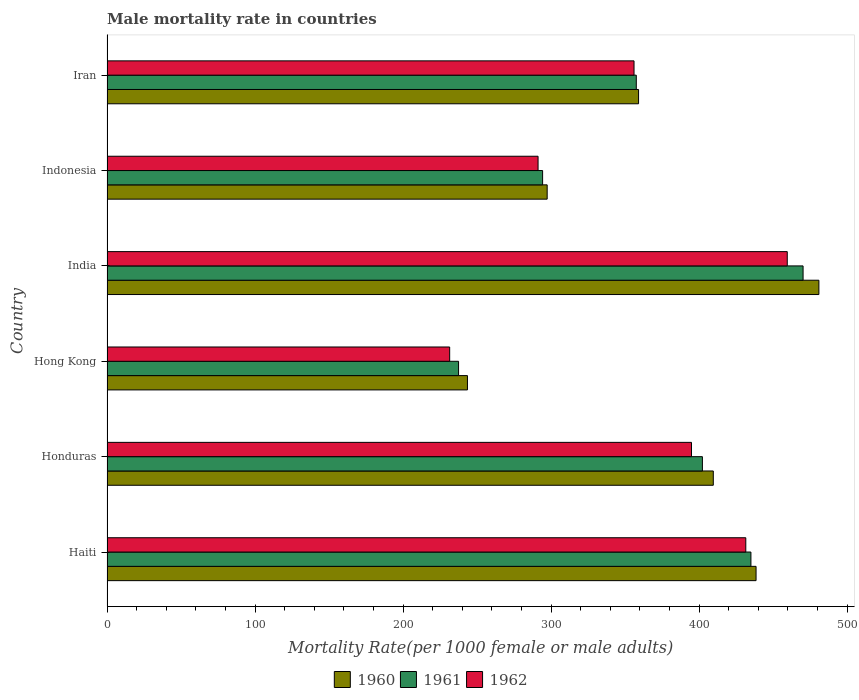How many groups of bars are there?
Keep it short and to the point. 6. How many bars are there on the 3rd tick from the top?
Make the answer very short. 3. What is the label of the 4th group of bars from the top?
Provide a succinct answer. Hong Kong. In how many cases, is the number of bars for a given country not equal to the number of legend labels?
Give a very brief answer. 0. What is the male mortality rate in 1960 in India?
Offer a very short reply. 480.88. Across all countries, what is the maximum male mortality rate in 1962?
Make the answer very short. 459.51. Across all countries, what is the minimum male mortality rate in 1960?
Provide a succinct answer. 243.48. In which country was the male mortality rate in 1962 maximum?
Offer a terse response. India. In which country was the male mortality rate in 1960 minimum?
Provide a succinct answer. Hong Kong. What is the total male mortality rate in 1960 in the graph?
Provide a short and direct response. 2228.73. What is the difference between the male mortality rate in 1961 in Hong Kong and that in India?
Offer a very short reply. -232.72. What is the difference between the male mortality rate in 1960 in India and the male mortality rate in 1962 in Haiti?
Offer a very short reply. 49.38. What is the average male mortality rate in 1960 per country?
Your answer should be compact. 371.46. What is the difference between the male mortality rate in 1960 and male mortality rate in 1961 in Indonesia?
Give a very brief answer. 3.08. What is the ratio of the male mortality rate in 1961 in Haiti to that in India?
Provide a succinct answer. 0.93. What is the difference between the highest and the second highest male mortality rate in 1961?
Your answer should be very brief. 35.23. What is the difference between the highest and the lowest male mortality rate in 1961?
Keep it short and to the point. 232.72. Is the sum of the male mortality rate in 1960 in Hong Kong and Iran greater than the maximum male mortality rate in 1961 across all countries?
Provide a short and direct response. Yes. Is it the case that in every country, the sum of the male mortality rate in 1960 and male mortality rate in 1961 is greater than the male mortality rate in 1962?
Offer a very short reply. Yes. How many bars are there?
Your answer should be compact. 18. Are all the bars in the graph horizontal?
Offer a very short reply. Yes. What is the difference between two consecutive major ticks on the X-axis?
Ensure brevity in your answer.  100. Does the graph contain grids?
Give a very brief answer. No. Where does the legend appear in the graph?
Offer a terse response. Bottom center. How many legend labels are there?
Provide a short and direct response. 3. What is the title of the graph?
Offer a very short reply. Male mortality rate in countries. Does "1975" appear as one of the legend labels in the graph?
Your answer should be compact. No. What is the label or title of the X-axis?
Provide a short and direct response. Mortality Rate(per 1000 female or male adults). What is the label or title of the Y-axis?
Your response must be concise. Country. What is the Mortality Rate(per 1000 female or male adults) of 1960 in Haiti?
Provide a short and direct response. 438.43. What is the Mortality Rate(per 1000 female or male adults) of 1961 in Haiti?
Ensure brevity in your answer.  434.96. What is the Mortality Rate(per 1000 female or male adults) in 1962 in Haiti?
Make the answer very short. 431.5. What is the Mortality Rate(per 1000 female or male adults) in 1960 in Honduras?
Your answer should be compact. 409.55. What is the Mortality Rate(per 1000 female or male adults) in 1961 in Honduras?
Keep it short and to the point. 402.19. What is the Mortality Rate(per 1000 female or male adults) of 1962 in Honduras?
Provide a short and direct response. 394.82. What is the Mortality Rate(per 1000 female or male adults) of 1960 in Hong Kong?
Offer a terse response. 243.48. What is the Mortality Rate(per 1000 female or male adults) in 1961 in Hong Kong?
Ensure brevity in your answer.  237.47. What is the Mortality Rate(per 1000 female or male adults) in 1962 in Hong Kong?
Offer a terse response. 231.47. What is the Mortality Rate(per 1000 female or male adults) of 1960 in India?
Give a very brief answer. 480.88. What is the Mortality Rate(per 1000 female or male adults) of 1961 in India?
Your answer should be very brief. 470.19. What is the Mortality Rate(per 1000 female or male adults) in 1962 in India?
Offer a terse response. 459.51. What is the Mortality Rate(per 1000 female or male adults) in 1960 in Indonesia?
Make the answer very short. 297.33. What is the Mortality Rate(per 1000 female or male adults) of 1961 in Indonesia?
Ensure brevity in your answer.  294.25. What is the Mortality Rate(per 1000 female or male adults) of 1962 in Indonesia?
Your answer should be very brief. 291.18. What is the Mortality Rate(per 1000 female or male adults) of 1960 in Iran?
Make the answer very short. 359.06. What is the Mortality Rate(per 1000 female or male adults) in 1961 in Iran?
Your answer should be very brief. 357.53. What is the Mortality Rate(per 1000 female or male adults) of 1962 in Iran?
Your answer should be compact. 356. Across all countries, what is the maximum Mortality Rate(per 1000 female or male adults) of 1960?
Provide a short and direct response. 480.88. Across all countries, what is the maximum Mortality Rate(per 1000 female or male adults) in 1961?
Provide a short and direct response. 470.19. Across all countries, what is the maximum Mortality Rate(per 1000 female or male adults) in 1962?
Offer a terse response. 459.51. Across all countries, what is the minimum Mortality Rate(per 1000 female or male adults) in 1960?
Make the answer very short. 243.48. Across all countries, what is the minimum Mortality Rate(per 1000 female or male adults) of 1961?
Provide a succinct answer. 237.47. Across all countries, what is the minimum Mortality Rate(per 1000 female or male adults) in 1962?
Your answer should be very brief. 231.47. What is the total Mortality Rate(per 1000 female or male adults) in 1960 in the graph?
Provide a succinct answer. 2228.73. What is the total Mortality Rate(per 1000 female or male adults) in 1961 in the graph?
Keep it short and to the point. 2196.6. What is the total Mortality Rate(per 1000 female or male adults) in 1962 in the graph?
Offer a terse response. 2164.47. What is the difference between the Mortality Rate(per 1000 female or male adults) of 1960 in Haiti and that in Honduras?
Keep it short and to the point. 28.88. What is the difference between the Mortality Rate(per 1000 female or male adults) in 1961 in Haiti and that in Honduras?
Provide a short and direct response. 32.78. What is the difference between the Mortality Rate(per 1000 female or male adults) of 1962 in Haiti and that in Honduras?
Make the answer very short. 36.67. What is the difference between the Mortality Rate(per 1000 female or male adults) of 1960 in Haiti and that in Hong Kong?
Your response must be concise. 194.96. What is the difference between the Mortality Rate(per 1000 female or male adults) of 1961 in Haiti and that in Hong Kong?
Make the answer very short. 197.49. What is the difference between the Mortality Rate(per 1000 female or male adults) of 1962 in Haiti and that in Hong Kong?
Ensure brevity in your answer.  200.03. What is the difference between the Mortality Rate(per 1000 female or male adults) in 1960 in Haiti and that in India?
Provide a short and direct response. -42.45. What is the difference between the Mortality Rate(per 1000 female or male adults) of 1961 in Haiti and that in India?
Provide a succinct answer. -35.23. What is the difference between the Mortality Rate(per 1000 female or male adults) of 1962 in Haiti and that in India?
Your response must be concise. -28.01. What is the difference between the Mortality Rate(per 1000 female or male adults) in 1960 in Haiti and that in Indonesia?
Provide a succinct answer. 141.1. What is the difference between the Mortality Rate(per 1000 female or male adults) of 1961 in Haiti and that in Indonesia?
Provide a succinct answer. 140.71. What is the difference between the Mortality Rate(per 1000 female or male adults) in 1962 in Haiti and that in Indonesia?
Ensure brevity in your answer.  140.32. What is the difference between the Mortality Rate(per 1000 female or male adults) of 1960 in Haiti and that in Iran?
Your response must be concise. 79.37. What is the difference between the Mortality Rate(per 1000 female or male adults) of 1961 in Haiti and that in Iran?
Give a very brief answer. 77.44. What is the difference between the Mortality Rate(per 1000 female or male adults) of 1962 in Haiti and that in Iran?
Keep it short and to the point. 75.5. What is the difference between the Mortality Rate(per 1000 female or male adults) in 1960 in Honduras and that in Hong Kong?
Give a very brief answer. 166.07. What is the difference between the Mortality Rate(per 1000 female or male adults) of 1961 in Honduras and that in Hong Kong?
Your answer should be compact. 164.71. What is the difference between the Mortality Rate(per 1000 female or male adults) in 1962 in Honduras and that in Hong Kong?
Your answer should be very brief. 163.35. What is the difference between the Mortality Rate(per 1000 female or male adults) of 1960 in Honduras and that in India?
Ensure brevity in your answer.  -71.33. What is the difference between the Mortality Rate(per 1000 female or male adults) of 1961 in Honduras and that in India?
Provide a short and direct response. -68.01. What is the difference between the Mortality Rate(per 1000 female or male adults) in 1962 in Honduras and that in India?
Your response must be concise. -64.69. What is the difference between the Mortality Rate(per 1000 female or male adults) in 1960 in Honduras and that in Indonesia?
Offer a very short reply. 112.22. What is the difference between the Mortality Rate(per 1000 female or male adults) of 1961 in Honduras and that in Indonesia?
Your answer should be compact. 107.94. What is the difference between the Mortality Rate(per 1000 female or male adults) of 1962 in Honduras and that in Indonesia?
Ensure brevity in your answer.  103.65. What is the difference between the Mortality Rate(per 1000 female or male adults) in 1960 in Honduras and that in Iran?
Provide a short and direct response. 50.49. What is the difference between the Mortality Rate(per 1000 female or male adults) in 1961 in Honduras and that in Iran?
Your answer should be compact. 44.66. What is the difference between the Mortality Rate(per 1000 female or male adults) of 1962 in Honduras and that in Iran?
Your response must be concise. 38.82. What is the difference between the Mortality Rate(per 1000 female or male adults) in 1960 in Hong Kong and that in India?
Your response must be concise. -237.4. What is the difference between the Mortality Rate(per 1000 female or male adults) of 1961 in Hong Kong and that in India?
Offer a terse response. -232.72. What is the difference between the Mortality Rate(per 1000 female or male adults) of 1962 in Hong Kong and that in India?
Ensure brevity in your answer.  -228.04. What is the difference between the Mortality Rate(per 1000 female or male adults) in 1960 in Hong Kong and that in Indonesia?
Your response must be concise. -53.85. What is the difference between the Mortality Rate(per 1000 female or male adults) of 1961 in Hong Kong and that in Indonesia?
Offer a terse response. -56.78. What is the difference between the Mortality Rate(per 1000 female or male adults) in 1962 in Hong Kong and that in Indonesia?
Keep it short and to the point. -59.71. What is the difference between the Mortality Rate(per 1000 female or male adults) in 1960 in Hong Kong and that in Iran?
Offer a very short reply. -115.58. What is the difference between the Mortality Rate(per 1000 female or male adults) of 1961 in Hong Kong and that in Iran?
Make the answer very short. -120.06. What is the difference between the Mortality Rate(per 1000 female or male adults) in 1962 in Hong Kong and that in Iran?
Your answer should be very brief. -124.53. What is the difference between the Mortality Rate(per 1000 female or male adults) of 1960 in India and that in Indonesia?
Keep it short and to the point. 183.55. What is the difference between the Mortality Rate(per 1000 female or male adults) of 1961 in India and that in Indonesia?
Your response must be concise. 175.94. What is the difference between the Mortality Rate(per 1000 female or male adults) of 1962 in India and that in Indonesia?
Your answer should be very brief. 168.34. What is the difference between the Mortality Rate(per 1000 female or male adults) of 1960 in India and that in Iran?
Provide a short and direct response. 121.82. What is the difference between the Mortality Rate(per 1000 female or male adults) in 1961 in India and that in Iran?
Keep it short and to the point. 112.67. What is the difference between the Mortality Rate(per 1000 female or male adults) in 1962 in India and that in Iran?
Your answer should be very brief. 103.51. What is the difference between the Mortality Rate(per 1000 female or male adults) of 1960 in Indonesia and that in Iran?
Give a very brief answer. -61.73. What is the difference between the Mortality Rate(per 1000 female or male adults) in 1961 in Indonesia and that in Iran?
Your answer should be very brief. -63.28. What is the difference between the Mortality Rate(per 1000 female or male adults) of 1962 in Indonesia and that in Iran?
Provide a short and direct response. -64.82. What is the difference between the Mortality Rate(per 1000 female or male adults) in 1960 in Haiti and the Mortality Rate(per 1000 female or male adults) in 1961 in Honduras?
Your answer should be compact. 36.25. What is the difference between the Mortality Rate(per 1000 female or male adults) in 1960 in Haiti and the Mortality Rate(per 1000 female or male adults) in 1962 in Honduras?
Your answer should be compact. 43.61. What is the difference between the Mortality Rate(per 1000 female or male adults) in 1961 in Haiti and the Mortality Rate(per 1000 female or male adults) in 1962 in Honduras?
Your answer should be compact. 40.14. What is the difference between the Mortality Rate(per 1000 female or male adults) in 1960 in Haiti and the Mortality Rate(per 1000 female or male adults) in 1961 in Hong Kong?
Offer a very short reply. 200.96. What is the difference between the Mortality Rate(per 1000 female or male adults) in 1960 in Haiti and the Mortality Rate(per 1000 female or male adults) in 1962 in Hong Kong?
Give a very brief answer. 206.97. What is the difference between the Mortality Rate(per 1000 female or male adults) of 1961 in Haiti and the Mortality Rate(per 1000 female or male adults) of 1962 in Hong Kong?
Provide a short and direct response. 203.5. What is the difference between the Mortality Rate(per 1000 female or male adults) of 1960 in Haiti and the Mortality Rate(per 1000 female or male adults) of 1961 in India?
Give a very brief answer. -31.76. What is the difference between the Mortality Rate(per 1000 female or male adults) in 1960 in Haiti and the Mortality Rate(per 1000 female or male adults) in 1962 in India?
Your answer should be very brief. -21.08. What is the difference between the Mortality Rate(per 1000 female or male adults) of 1961 in Haiti and the Mortality Rate(per 1000 female or male adults) of 1962 in India?
Make the answer very short. -24.55. What is the difference between the Mortality Rate(per 1000 female or male adults) of 1960 in Haiti and the Mortality Rate(per 1000 female or male adults) of 1961 in Indonesia?
Provide a succinct answer. 144.18. What is the difference between the Mortality Rate(per 1000 female or male adults) of 1960 in Haiti and the Mortality Rate(per 1000 female or male adults) of 1962 in Indonesia?
Give a very brief answer. 147.26. What is the difference between the Mortality Rate(per 1000 female or male adults) of 1961 in Haiti and the Mortality Rate(per 1000 female or male adults) of 1962 in Indonesia?
Offer a very short reply. 143.79. What is the difference between the Mortality Rate(per 1000 female or male adults) in 1960 in Haiti and the Mortality Rate(per 1000 female or male adults) in 1961 in Iran?
Your response must be concise. 80.9. What is the difference between the Mortality Rate(per 1000 female or male adults) in 1960 in Haiti and the Mortality Rate(per 1000 female or male adults) in 1962 in Iran?
Your answer should be compact. 82.44. What is the difference between the Mortality Rate(per 1000 female or male adults) in 1961 in Haiti and the Mortality Rate(per 1000 female or male adults) in 1962 in Iran?
Keep it short and to the point. 78.97. What is the difference between the Mortality Rate(per 1000 female or male adults) of 1960 in Honduras and the Mortality Rate(per 1000 female or male adults) of 1961 in Hong Kong?
Your response must be concise. 172.08. What is the difference between the Mortality Rate(per 1000 female or male adults) in 1960 in Honduras and the Mortality Rate(per 1000 female or male adults) in 1962 in Hong Kong?
Provide a succinct answer. 178.08. What is the difference between the Mortality Rate(per 1000 female or male adults) in 1961 in Honduras and the Mortality Rate(per 1000 female or male adults) in 1962 in Hong Kong?
Offer a very short reply. 170.72. What is the difference between the Mortality Rate(per 1000 female or male adults) in 1960 in Honduras and the Mortality Rate(per 1000 female or male adults) in 1961 in India?
Your response must be concise. -60.64. What is the difference between the Mortality Rate(per 1000 female or male adults) in 1960 in Honduras and the Mortality Rate(per 1000 female or male adults) in 1962 in India?
Give a very brief answer. -49.96. What is the difference between the Mortality Rate(per 1000 female or male adults) of 1961 in Honduras and the Mortality Rate(per 1000 female or male adults) of 1962 in India?
Make the answer very short. -57.32. What is the difference between the Mortality Rate(per 1000 female or male adults) in 1960 in Honduras and the Mortality Rate(per 1000 female or male adults) in 1961 in Indonesia?
Keep it short and to the point. 115.3. What is the difference between the Mortality Rate(per 1000 female or male adults) of 1960 in Honduras and the Mortality Rate(per 1000 female or male adults) of 1962 in Indonesia?
Offer a terse response. 118.38. What is the difference between the Mortality Rate(per 1000 female or male adults) in 1961 in Honduras and the Mortality Rate(per 1000 female or male adults) in 1962 in Indonesia?
Your answer should be very brief. 111.01. What is the difference between the Mortality Rate(per 1000 female or male adults) of 1960 in Honduras and the Mortality Rate(per 1000 female or male adults) of 1961 in Iran?
Provide a short and direct response. 52.02. What is the difference between the Mortality Rate(per 1000 female or male adults) in 1960 in Honduras and the Mortality Rate(per 1000 female or male adults) in 1962 in Iran?
Give a very brief answer. 53.55. What is the difference between the Mortality Rate(per 1000 female or male adults) of 1961 in Honduras and the Mortality Rate(per 1000 female or male adults) of 1962 in Iran?
Ensure brevity in your answer.  46.19. What is the difference between the Mortality Rate(per 1000 female or male adults) of 1960 in Hong Kong and the Mortality Rate(per 1000 female or male adults) of 1961 in India?
Keep it short and to the point. -226.72. What is the difference between the Mortality Rate(per 1000 female or male adults) of 1960 in Hong Kong and the Mortality Rate(per 1000 female or male adults) of 1962 in India?
Ensure brevity in your answer.  -216.03. What is the difference between the Mortality Rate(per 1000 female or male adults) in 1961 in Hong Kong and the Mortality Rate(per 1000 female or male adults) in 1962 in India?
Offer a very short reply. -222.04. What is the difference between the Mortality Rate(per 1000 female or male adults) of 1960 in Hong Kong and the Mortality Rate(per 1000 female or male adults) of 1961 in Indonesia?
Provide a short and direct response. -50.77. What is the difference between the Mortality Rate(per 1000 female or male adults) of 1960 in Hong Kong and the Mortality Rate(per 1000 female or male adults) of 1962 in Indonesia?
Provide a succinct answer. -47.7. What is the difference between the Mortality Rate(per 1000 female or male adults) of 1961 in Hong Kong and the Mortality Rate(per 1000 female or male adults) of 1962 in Indonesia?
Keep it short and to the point. -53.7. What is the difference between the Mortality Rate(per 1000 female or male adults) in 1960 in Hong Kong and the Mortality Rate(per 1000 female or male adults) in 1961 in Iran?
Your response must be concise. -114.05. What is the difference between the Mortality Rate(per 1000 female or male adults) in 1960 in Hong Kong and the Mortality Rate(per 1000 female or male adults) in 1962 in Iran?
Your response must be concise. -112.52. What is the difference between the Mortality Rate(per 1000 female or male adults) of 1961 in Hong Kong and the Mortality Rate(per 1000 female or male adults) of 1962 in Iran?
Ensure brevity in your answer.  -118.53. What is the difference between the Mortality Rate(per 1000 female or male adults) of 1960 in India and the Mortality Rate(per 1000 female or male adults) of 1961 in Indonesia?
Offer a very short reply. 186.63. What is the difference between the Mortality Rate(per 1000 female or male adults) in 1960 in India and the Mortality Rate(per 1000 female or male adults) in 1962 in Indonesia?
Ensure brevity in your answer.  189.7. What is the difference between the Mortality Rate(per 1000 female or male adults) in 1961 in India and the Mortality Rate(per 1000 female or male adults) in 1962 in Indonesia?
Ensure brevity in your answer.  179.02. What is the difference between the Mortality Rate(per 1000 female or male adults) of 1960 in India and the Mortality Rate(per 1000 female or male adults) of 1961 in Iran?
Provide a short and direct response. 123.35. What is the difference between the Mortality Rate(per 1000 female or male adults) of 1960 in India and the Mortality Rate(per 1000 female or male adults) of 1962 in Iran?
Ensure brevity in your answer.  124.88. What is the difference between the Mortality Rate(per 1000 female or male adults) of 1961 in India and the Mortality Rate(per 1000 female or male adults) of 1962 in Iran?
Make the answer very short. 114.2. What is the difference between the Mortality Rate(per 1000 female or male adults) of 1960 in Indonesia and the Mortality Rate(per 1000 female or male adults) of 1961 in Iran?
Offer a terse response. -60.2. What is the difference between the Mortality Rate(per 1000 female or male adults) of 1960 in Indonesia and the Mortality Rate(per 1000 female or male adults) of 1962 in Iran?
Your response must be concise. -58.67. What is the difference between the Mortality Rate(per 1000 female or male adults) of 1961 in Indonesia and the Mortality Rate(per 1000 female or male adults) of 1962 in Iran?
Offer a very short reply. -61.75. What is the average Mortality Rate(per 1000 female or male adults) of 1960 per country?
Provide a short and direct response. 371.46. What is the average Mortality Rate(per 1000 female or male adults) of 1961 per country?
Ensure brevity in your answer.  366.1. What is the average Mortality Rate(per 1000 female or male adults) in 1962 per country?
Offer a terse response. 360.75. What is the difference between the Mortality Rate(per 1000 female or male adults) in 1960 and Mortality Rate(per 1000 female or male adults) in 1961 in Haiti?
Make the answer very short. 3.47. What is the difference between the Mortality Rate(per 1000 female or male adults) of 1960 and Mortality Rate(per 1000 female or male adults) of 1962 in Haiti?
Your answer should be compact. 6.94. What is the difference between the Mortality Rate(per 1000 female or male adults) of 1961 and Mortality Rate(per 1000 female or male adults) of 1962 in Haiti?
Offer a very short reply. 3.47. What is the difference between the Mortality Rate(per 1000 female or male adults) in 1960 and Mortality Rate(per 1000 female or male adults) in 1961 in Honduras?
Offer a terse response. 7.36. What is the difference between the Mortality Rate(per 1000 female or male adults) of 1960 and Mortality Rate(per 1000 female or male adults) of 1962 in Honduras?
Offer a terse response. 14.73. What is the difference between the Mortality Rate(per 1000 female or male adults) in 1961 and Mortality Rate(per 1000 female or male adults) in 1962 in Honduras?
Your response must be concise. 7.37. What is the difference between the Mortality Rate(per 1000 female or male adults) in 1960 and Mortality Rate(per 1000 female or male adults) in 1961 in Hong Kong?
Offer a terse response. 6. What is the difference between the Mortality Rate(per 1000 female or male adults) in 1960 and Mortality Rate(per 1000 female or male adults) in 1962 in Hong Kong?
Provide a succinct answer. 12.01. What is the difference between the Mortality Rate(per 1000 female or male adults) of 1961 and Mortality Rate(per 1000 female or male adults) of 1962 in Hong Kong?
Keep it short and to the point. 6. What is the difference between the Mortality Rate(per 1000 female or male adults) in 1960 and Mortality Rate(per 1000 female or male adults) in 1961 in India?
Offer a very short reply. 10.68. What is the difference between the Mortality Rate(per 1000 female or male adults) in 1960 and Mortality Rate(per 1000 female or male adults) in 1962 in India?
Your response must be concise. 21.37. What is the difference between the Mortality Rate(per 1000 female or male adults) of 1961 and Mortality Rate(per 1000 female or male adults) of 1962 in India?
Your response must be concise. 10.68. What is the difference between the Mortality Rate(per 1000 female or male adults) in 1960 and Mortality Rate(per 1000 female or male adults) in 1961 in Indonesia?
Keep it short and to the point. 3.08. What is the difference between the Mortality Rate(per 1000 female or male adults) of 1960 and Mortality Rate(per 1000 female or male adults) of 1962 in Indonesia?
Provide a succinct answer. 6.15. What is the difference between the Mortality Rate(per 1000 female or male adults) in 1961 and Mortality Rate(per 1000 female or male adults) in 1962 in Indonesia?
Offer a terse response. 3.08. What is the difference between the Mortality Rate(per 1000 female or male adults) in 1960 and Mortality Rate(per 1000 female or male adults) in 1961 in Iran?
Give a very brief answer. 1.53. What is the difference between the Mortality Rate(per 1000 female or male adults) in 1960 and Mortality Rate(per 1000 female or male adults) in 1962 in Iran?
Your answer should be compact. 3.06. What is the difference between the Mortality Rate(per 1000 female or male adults) in 1961 and Mortality Rate(per 1000 female or male adults) in 1962 in Iran?
Your answer should be compact. 1.53. What is the ratio of the Mortality Rate(per 1000 female or male adults) in 1960 in Haiti to that in Honduras?
Ensure brevity in your answer.  1.07. What is the ratio of the Mortality Rate(per 1000 female or male adults) of 1961 in Haiti to that in Honduras?
Offer a very short reply. 1.08. What is the ratio of the Mortality Rate(per 1000 female or male adults) in 1962 in Haiti to that in Honduras?
Offer a terse response. 1.09. What is the ratio of the Mortality Rate(per 1000 female or male adults) in 1960 in Haiti to that in Hong Kong?
Offer a very short reply. 1.8. What is the ratio of the Mortality Rate(per 1000 female or male adults) in 1961 in Haiti to that in Hong Kong?
Keep it short and to the point. 1.83. What is the ratio of the Mortality Rate(per 1000 female or male adults) in 1962 in Haiti to that in Hong Kong?
Your answer should be compact. 1.86. What is the ratio of the Mortality Rate(per 1000 female or male adults) of 1960 in Haiti to that in India?
Ensure brevity in your answer.  0.91. What is the ratio of the Mortality Rate(per 1000 female or male adults) in 1961 in Haiti to that in India?
Ensure brevity in your answer.  0.93. What is the ratio of the Mortality Rate(per 1000 female or male adults) in 1962 in Haiti to that in India?
Ensure brevity in your answer.  0.94. What is the ratio of the Mortality Rate(per 1000 female or male adults) in 1960 in Haiti to that in Indonesia?
Your answer should be very brief. 1.47. What is the ratio of the Mortality Rate(per 1000 female or male adults) of 1961 in Haiti to that in Indonesia?
Make the answer very short. 1.48. What is the ratio of the Mortality Rate(per 1000 female or male adults) in 1962 in Haiti to that in Indonesia?
Your answer should be compact. 1.48. What is the ratio of the Mortality Rate(per 1000 female or male adults) of 1960 in Haiti to that in Iran?
Give a very brief answer. 1.22. What is the ratio of the Mortality Rate(per 1000 female or male adults) in 1961 in Haiti to that in Iran?
Offer a terse response. 1.22. What is the ratio of the Mortality Rate(per 1000 female or male adults) in 1962 in Haiti to that in Iran?
Offer a terse response. 1.21. What is the ratio of the Mortality Rate(per 1000 female or male adults) of 1960 in Honduras to that in Hong Kong?
Provide a short and direct response. 1.68. What is the ratio of the Mortality Rate(per 1000 female or male adults) of 1961 in Honduras to that in Hong Kong?
Ensure brevity in your answer.  1.69. What is the ratio of the Mortality Rate(per 1000 female or male adults) of 1962 in Honduras to that in Hong Kong?
Your answer should be very brief. 1.71. What is the ratio of the Mortality Rate(per 1000 female or male adults) in 1960 in Honduras to that in India?
Your answer should be compact. 0.85. What is the ratio of the Mortality Rate(per 1000 female or male adults) in 1961 in Honduras to that in India?
Ensure brevity in your answer.  0.86. What is the ratio of the Mortality Rate(per 1000 female or male adults) of 1962 in Honduras to that in India?
Provide a succinct answer. 0.86. What is the ratio of the Mortality Rate(per 1000 female or male adults) in 1960 in Honduras to that in Indonesia?
Offer a terse response. 1.38. What is the ratio of the Mortality Rate(per 1000 female or male adults) in 1961 in Honduras to that in Indonesia?
Give a very brief answer. 1.37. What is the ratio of the Mortality Rate(per 1000 female or male adults) of 1962 in Honduras to that in Indonesia?
Provide a succinct answer. 1.36. What is the ratio of the Mortality Rate(per 1000 female or male adults) of 1960 in Honduras to that in Iran?
Offer a very short reply. 1.14. What is the ratio of the Mortality Rate(per 1000 female or male adults) in 1961 in Honduras to that in Iran?
Keep it short and to the point. 1.12. What is the ratio of the Mortality Rate(per 1000 female or male adults) of 1962 in Honduras to that in Iran?
Your answer should be compact. 1.11. What is the ratio of the Mortality Rate(per 1000 female or male adults) of 1960 in Hong Kong to that in India?
Your response must be concise. 0.51. What is the ratio of the Mortality Rate(per 1000 female or male adults) of 1961 in Hong Kong to that in India?
Offer a very short reply. 0.51. What is the ratio of the Mortality Rate(per 1000 female or male adults) of 1962 in Hong Kong to that in India?
Offer a terse response. 0.5. What is the ratio of the Mortality Rate(per 1000 female or male adults) in 1960 in Hong Kong to that in Indonesia?
Provide a short and direct response. 0.82. What is the ratio of the Mortality Rate(per 1000 female or male adults) in 1961 in Hong Kong to that in Indonesia?
Provide a succinct answer. 0.81. What is the ratio of the Mortality Rate(per 1000 female or male adults) in 1962 in Hong Kong to that in Indonesia?
Offer a very short reply. 0.79. What is the ratio of the Mortality Rate(per 1000 female or male adults) of 1960 in Hong Kong to that in Iran?
Your response must be concise. 0.68. What is the ratio of the Mortality Rate(per 1000 female or male adults) of 1961 in Hong Kong to that in Iran?
Give a very brief answer. 0.66. What is the ratio of the Mortality Rate(per 1000 female or male adults) of 1962 in Hong Kong to that in Iran?
Make the answer very short. 0.65. What is the ratio of the Mortality Rate(per 1000 female or male adults) of 1960 in India to that in Indonesia?
Ensure brevity in your answer.  1.62. What is the ratio of the Mortality Rate(per 1000 female or male adults) in 1961 in India to that in Indonesia?
Offer a very short reply. 1.6. What is the ratio of the Mortality Rate(per 1000 female or male adults) in 1962 in India to that in Indonesia?
Offer a terse response. 1.58. What is the ratio of the Mortality Rate(per 1000 female or male adults) in 1960 in India to that in Iran?
Offer a very short reply. 1.34. What is the ratio of the Mortality Rate(per 1000 female or male adults) in 1961 in India to that in Iran?
Your answer should be very brief. 1.32. What is the ratio of the Mortality Rate(per 1000 female or male adults) in 1962 in India to that in Iran?
Provide a succinct answer. 1.29. What is the ratio of the Mortality Rate(per 1000 female or male adults) of 1960 in Indonesia to that in Iran?
Offer a very short reply. 0.83. What is the ratio of the Mortality Rate(per 1000 female or male adults) in 1961 in Indonesia to that in Iran?
Provide a succinct answer. 0.82. What is the ratio of the Mortality Rate(per 1000 female or male adults) of 1962 in Indonesia to that in Iran?
Keep it short and to the point. 0.82. What is the difference between the highest and the second highest Mortality Rate(per 1000 female or male adults) in 1960?
Give a very brief answer. 42.45. What is the difference between the highest and the second highest Mortality Rate(per 1000 female or male adults) of 1961?
Provide a short and direct response. 35.23. What is the difference between the highest and the second highest Mortality Rate(per 1000 female or male adults) of 1962?
Provide a succinct answer. 28.01. What is the difference between the highest and the lowest Mortality Rate(per 1000 female or male adults) in 1960?
Keep it short and to the point. 237.4. What is the difference between the highest and the lowest Mortality Rate(per 1000 female or male adults) of 1961?
Provide a succinct answer. 232.72. What is the difference between the highest and the lowest Mortality Rate(per 1000 female or male adults) of 1962?
Your answer should be compact. 228.04. 